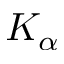Convert formula to latex. <formula><loc_0><loc_0><loc_500><loc_500>K _ { \alpha }</formula> 